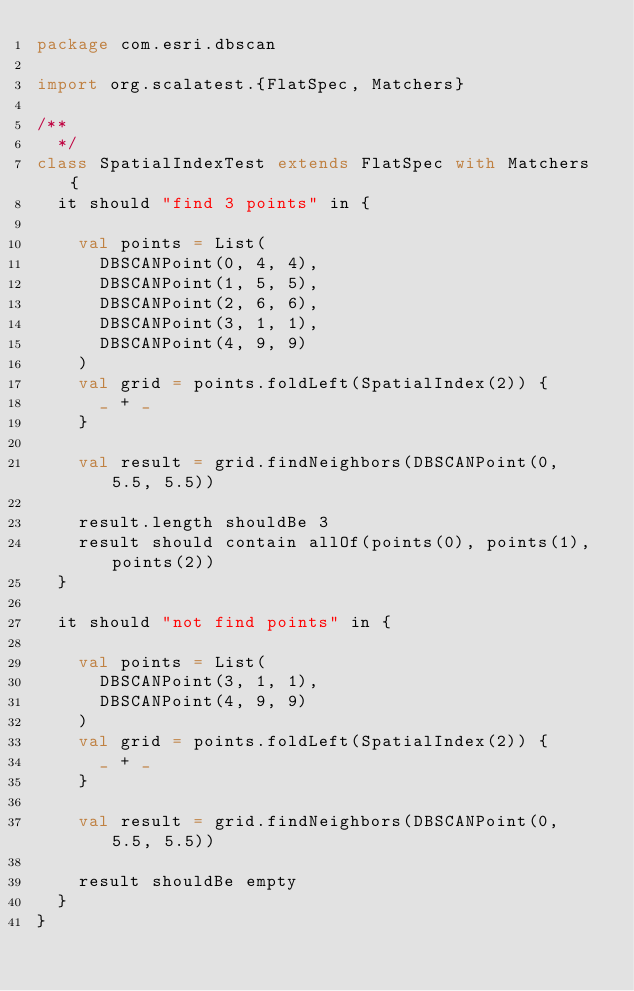<code> <loc_0><loc_0><loc_500><loc_500><_Scala_>package com.esri.dbscan

import org.scalatest.{FlatSpec, Matchers}

/**
  */
class SpatialIndexTest extends FlatSpec with Matchers {
  it should "find 3 points" in {

    val points = List(
      DBSCANPoint(0, 4, 4),
      DBSCANPoint(1, 5, 5),
      DBSCANPoint(2, 6, 6),
      DBSCANPoint(3, 1, 1),
      DBSCANPoint(4, 9, 9)
    )
    val grid = points.foldLeft(SpatialIndex(2)) {
      _ + _
    }

    val result = grid.findNeighbors(DBSCANPoint(0, 5.5, 5.5))

    result.length shouldBe 3
    result should contain allOf(points(0), points(1), points(2))
  }

  it should "not find points" in {

    val points = List(
      DBSCANPoint(3, 1, 1),
      DBSCANPoint(4, 9, 9)
    )
    val grid = points.foldLeft(SpatialIndex(2)) {
      _ + _
    }

    val result = grid.findNeighbors(DBSCANPoint(0, 5.5, 5.5))

    result shouldBe empty
  }
}
</code> 